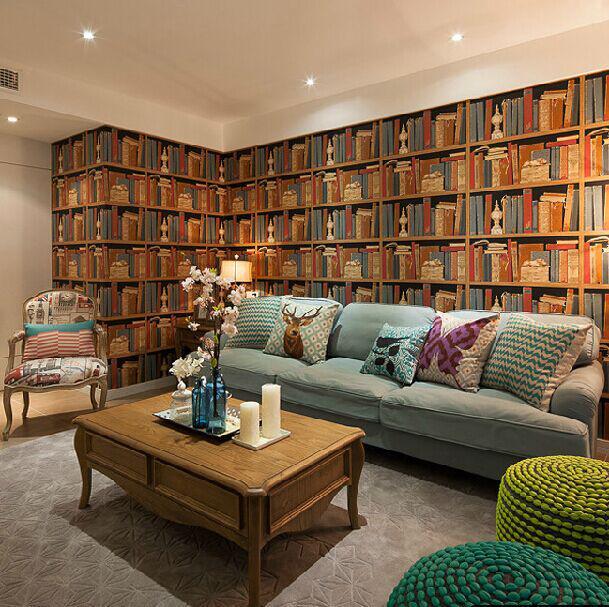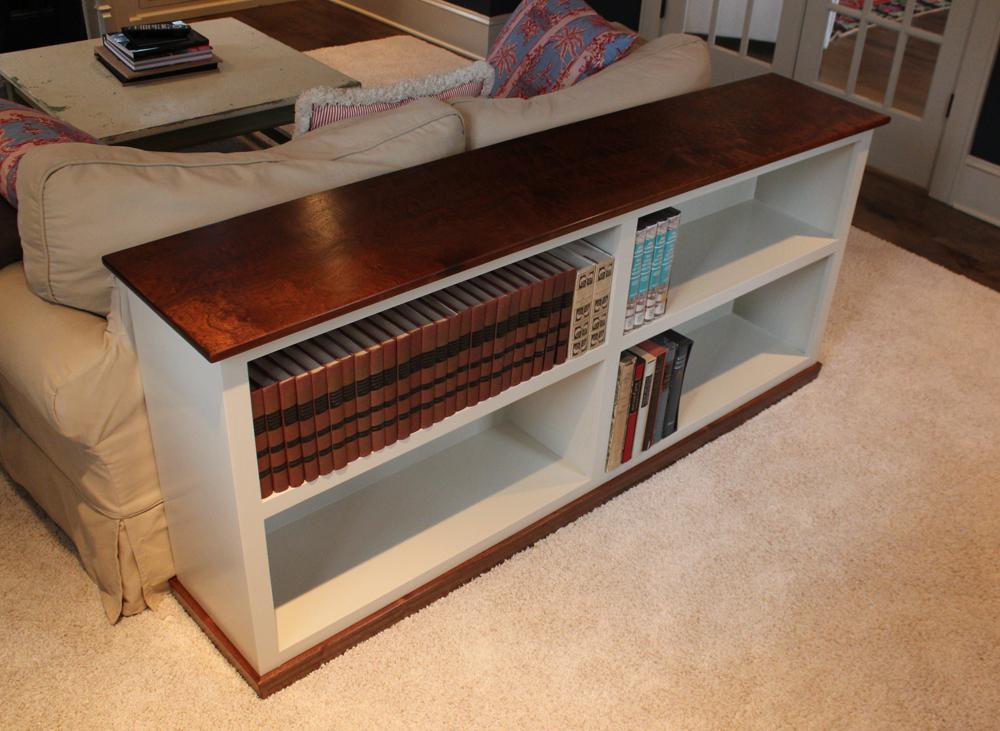The first image is the image on the left, the second image is the image on the right. For the images shown, is this caption "In the right image the bookshelf has four different shelves with the bottom left shelf being empty." true? Answer yes or no. Yes. The first image is the image on the left, the second image is the image on the right. Assess this claim about the two images: "There is a 4 cubby bookshelf up against a sofa back with books in the shelf". Correct or not? Answer yes or no. Yes. 